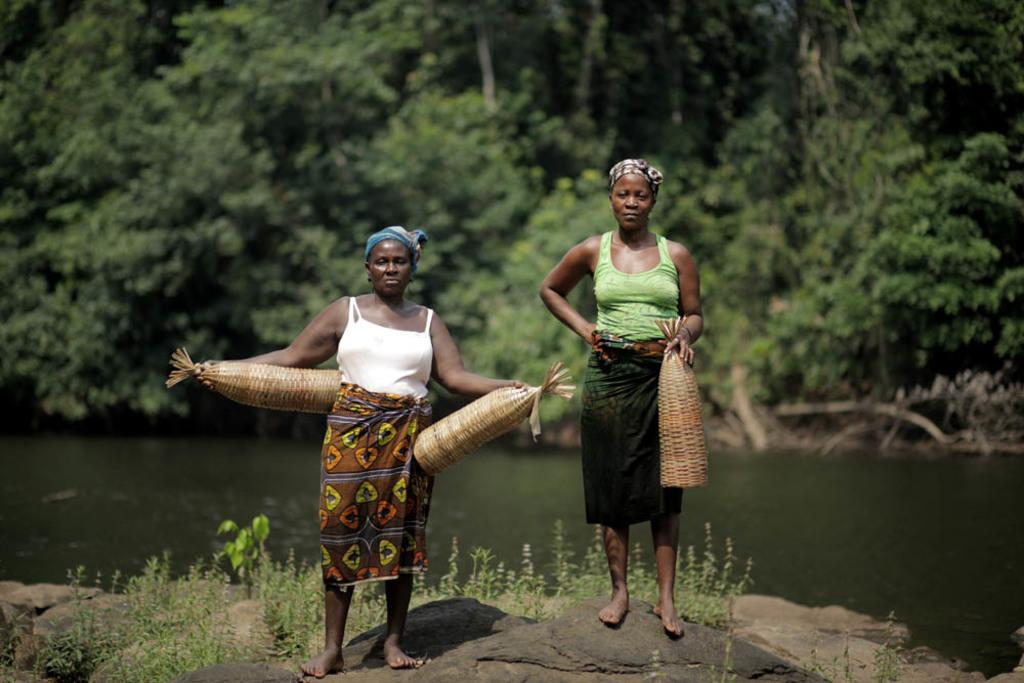How many people are in the image? There are two persons standing on a stone in the image. What is visible in the background of the image? Water, trees, and plants are visible in the background of the image. What type of pancake is being served to the creature in the image? There is no creature or pancake present in the image. Is it raining in the image? The provided facts do not mention any rain in the image. 